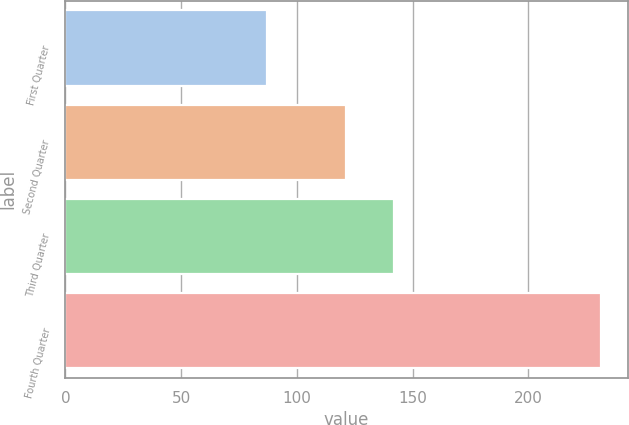Convert chart. <chart><loc_0><loc_0><loc_500><loc_500><bar_chart><fcel>First Quarter<fcel>Second Quarter<fcel>Third Quarter<fcel>Fourth Quarter<nl><fcel>87.11<fcel>121.19<fcel>141.91<fcel>231.4<nl></chart> 